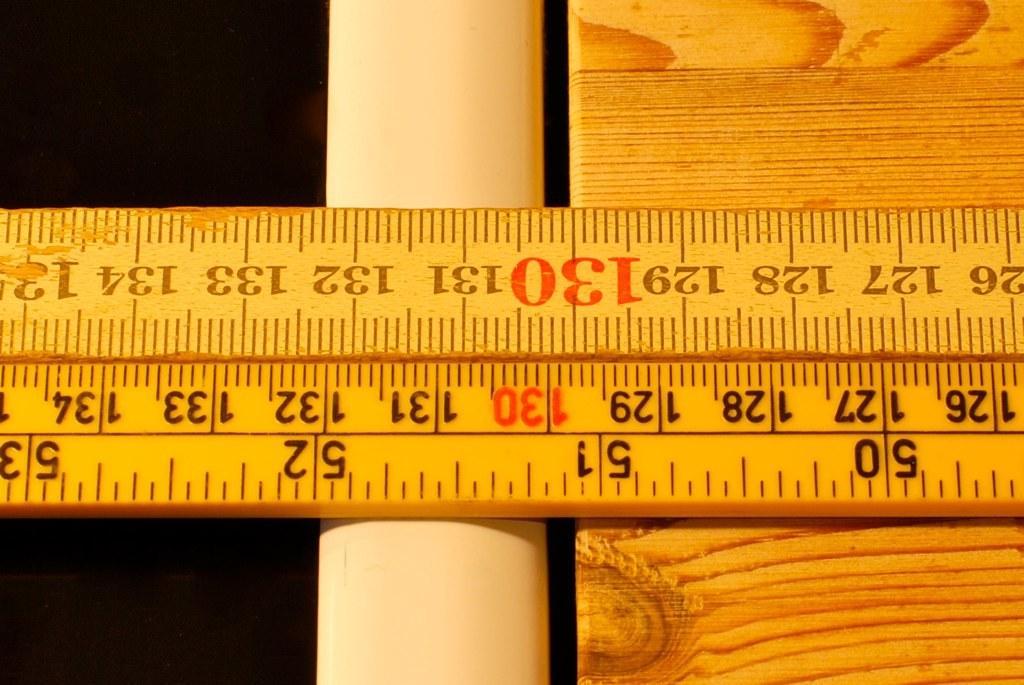Could you give a brief overview of what you see in this image? We can see scale on wooden platform and paper. In the background of the image it is dark. 